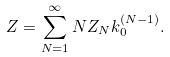<formula> <loc_0><loc_0><loc_500><loc_500>Z = \sum _ { N = 1 } ^ { \infty } N Z _ { N } k _ { 0 } ^ { ( N - 1 ) } .</formula> 